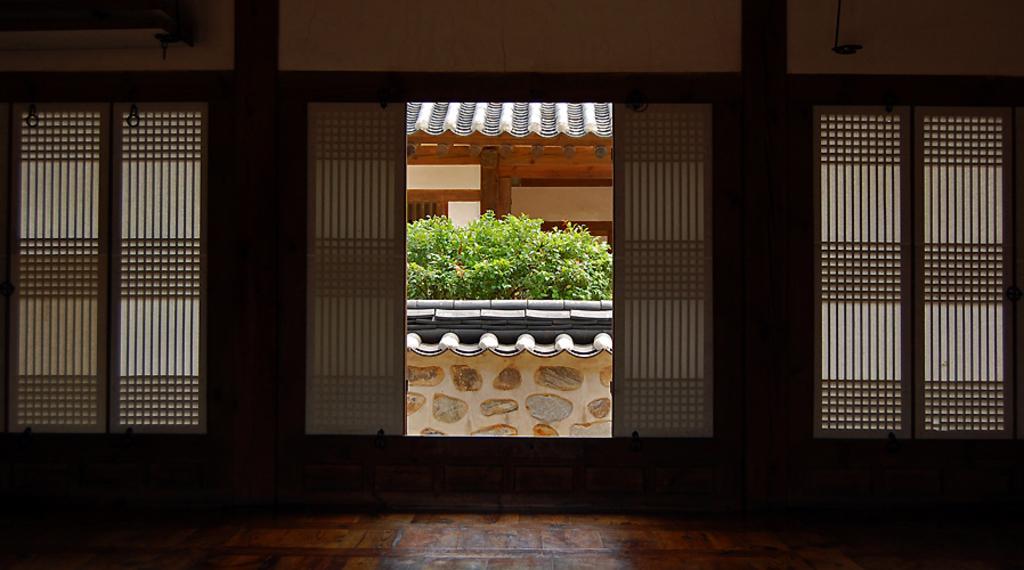Describe this image in one or two sentences. In the picture we can see inside the house with a wooden floor and entrance from the entrance we can see outside with the wall and some plants behind it and behind it we can see another house. 